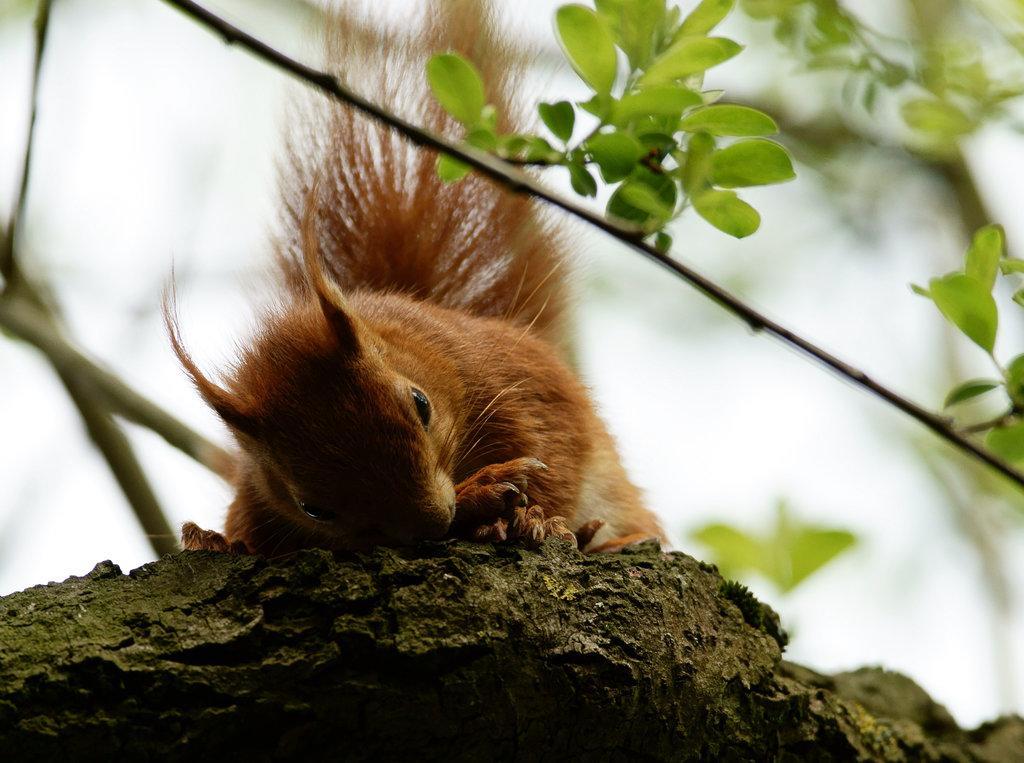Can you describe this image briefly? Background portion of the picture is blur and we can see green leaves, stems and a squirrel on a surface. 